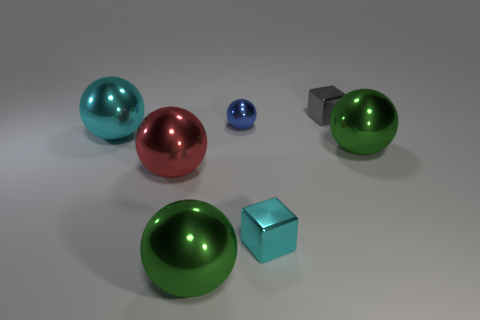There is a big red object that is in front of the metallic block behind the small cyan shiny object; is there a big red metal ball that is on the right side of it?
Provide a short and direct response. No. Is there any other thing that has the same shape as the big red metal thing?
Your answer should be very brief. Yes. Is the color of the tiny shiny block that is on the left side of the gray block the same as the ball that is in front of the large red metallic sphere?
Your response must be concise. No. Are there any gray balls?
Make the answer very short. No. How big is the gray metallic block that is behind the small metal block in front of the small object behind the blue sphere?
Keep it short and to the point. Small. There is a small cyan metal thing; does it have the same shape as the shiny object behind the blue metal object?
Provide a succinct answer. Yes. Are there any other small metal balls of the same color as the small sphere?
Provide a short and direct response. No. What number of cylinders are big objects or gray shiny objects?
Ensure brevity in your answer.  0. Are there any other matte objects that have the same shape as the red object?
Keep it short and to the point. No. How many other objects are there of the same color as the small shiny ball?
Your answer should be very brief. 0. 